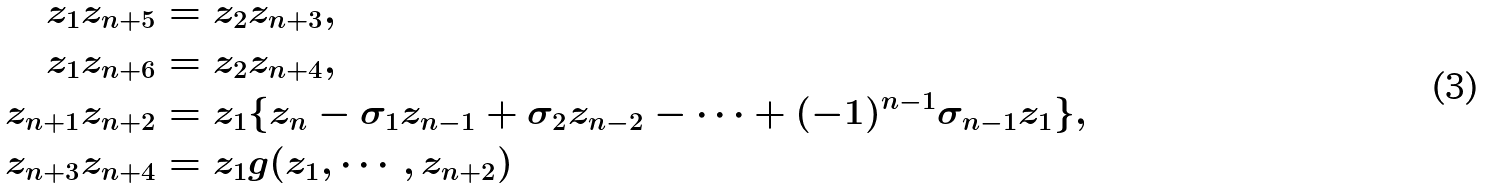<formula> <loc_0><loc_0><loc_500><loc_500>z _ { 1 } z _ { n + 5 } & = z _ { 2 } z _ { n + 3 } , \\ z _ { 1 } z _ { n + 6 } & = z _ { 2 } z _ { n + 4 } , \\ z _ { n + 1 } z _ { n + 2 } & = z _ { 1 } \{ z _ { n } - \sigma _ { 1 } z _ { n - 1 } + \sigma _ { 2 } z _ { n - 2 } - \cdots + ( - 1 ) ^ { n - 1 } \sigma _ { n - 1 } z _ { 1 } \} , \\ z _ { n + 3 } z _ { n + 4 } & = z _ { 1 } g ( z _ { 1 } , \cdots , z _ { n + 2 } )</formula> 